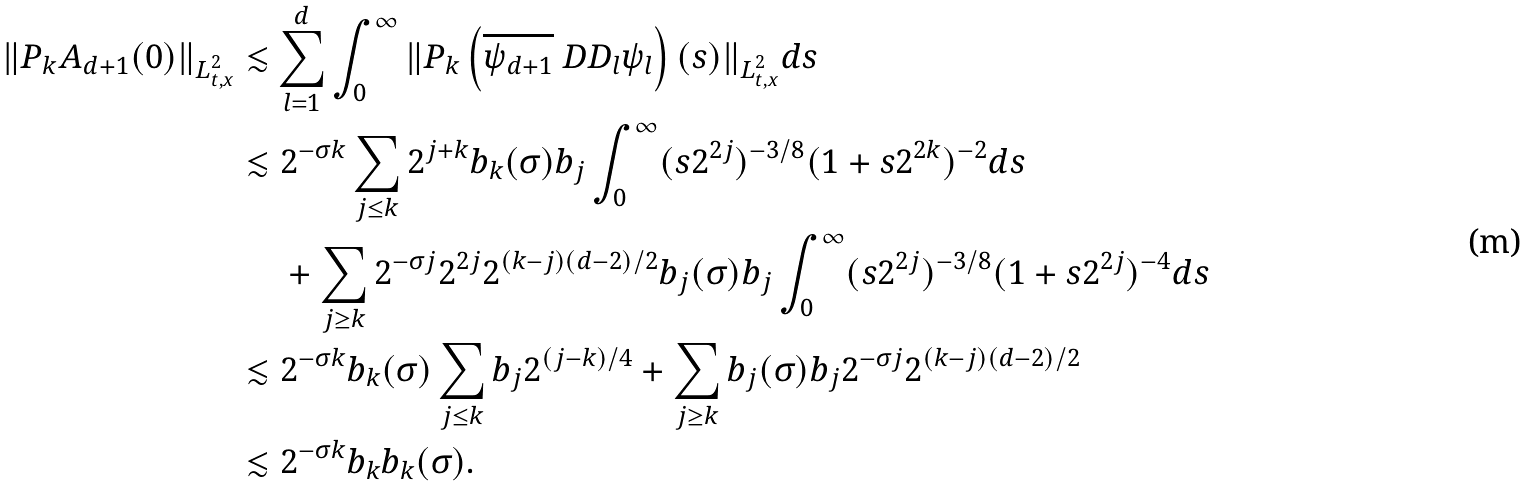<formula> <loc_0><loc_0><loc_500><loc_500>\| P _ { k } A _ { d + 1 } ( 0 ) \| _ { L ^ { 2 } _ { t , x } } \lesssim & \sum _ { l = 1 } ^ { d } \int _ { 0 } ^ { \infty } \| P _ { k } \left ( \overline { \psi _ { d + 1 } } \ D D _ { l } \psi _ { l } \right ) ( s ) \| _ { L ^ { 2 } _ { t , x } } d s \\ \lesssim & \ 2 ^ { - \sigma k } \sum _ { j \leq k } 2 ^ { j + k } b _ { k } ( \sigma ) b _ { j } \int _ { 0 } ^ { \infty } ( s 2 ^ { 2 j } ) ^ { - 3 / 8 } ( 1 + s 2 ^ { 2 k } ) ^ { - 2 } d s \\ & \ + \sum _ { { j } \geq k } 2 ^ { - \sigma { j } } 2 ^ { 2 j } 2 ^ { ( k - { j } ) ( d - 2 ) / 2 } b _ { j } ( \sigma ) b _ { j } \int _ { 0 } ^ { \infty } ( s 2 ^ { 2 { j } } ) ^ { - 3 / 8 } ( 1 + s 2 ^ { 2 { j } } ) ^ { - 4 } d s \\ \lesssim & \ 2 ^ { - \sigma k } b _ { k } ( \sigma ) \sum _ { { j } \leq k } b _ { j } 2 ^ { ( { j } - k ) / 4 } + \sum _ { { j } \geq k } b _ { j } ( \sigma ) b _ { j } 2 ^ { - \sigma { j } } 2 ^ { ( k - { j } ) ( d - 2 ) / 2 } \\ \lesssim & \ 2 ^ { - \sigma k } b _ { k } b _ { k } ( \sigma ) .</formula> 